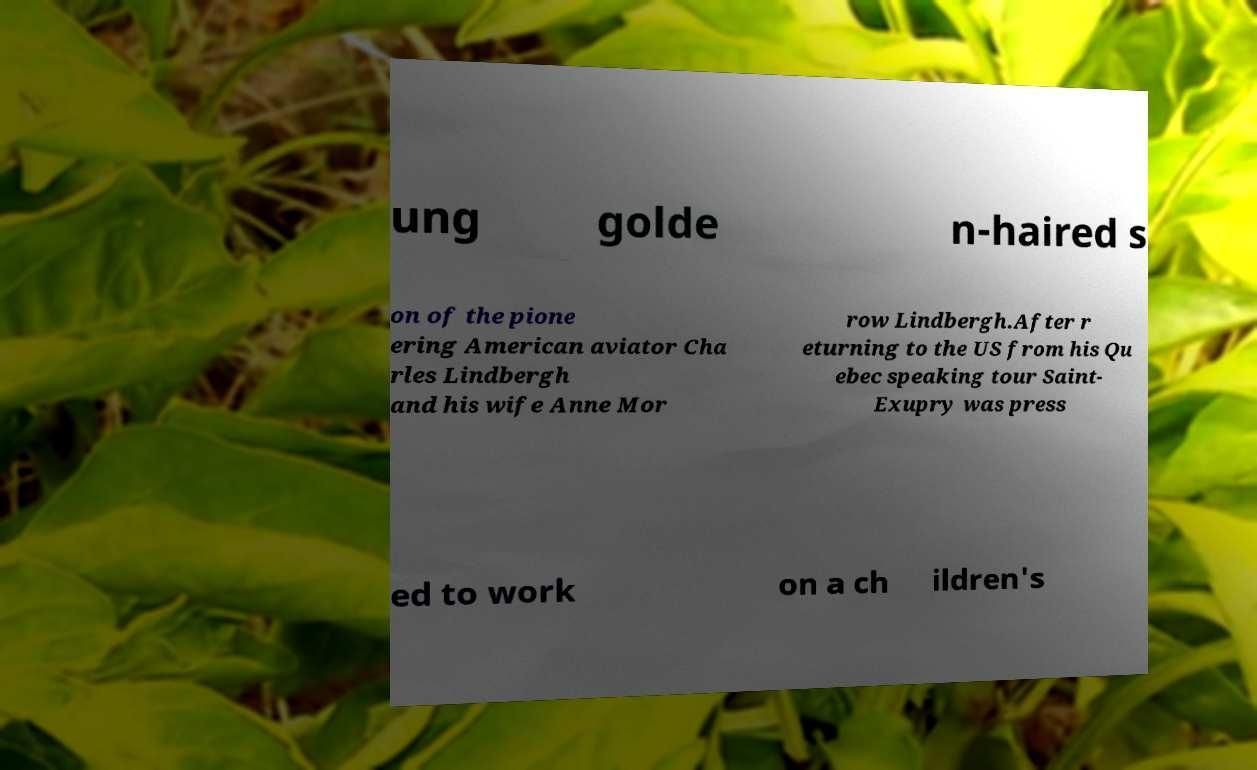There's text embedded in this image that I need extracted. Can you transcribe it verbatim? ung golde n-haired s on of the pione ering American aviator Cha rles Lindbergh and his wife Anne Mor row Lindbergh.After r eturning to the US from his Qu ebec speaking tour Saint- Exupry was press ed to work on a ch ildren's 